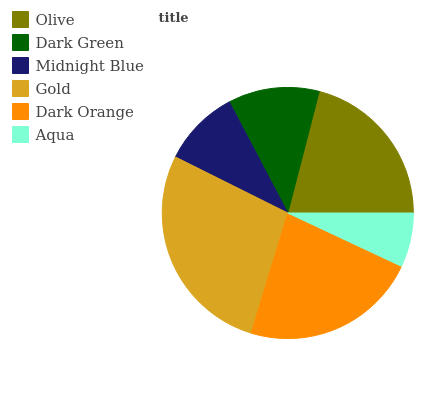Is Aqua the minimum?
Answer yes or no. Yes. Is Gold the maximum?
Answer yes or no. Yes. Is Dark Green the minimum?
Answer yes or no. No. Is Dark Green the maximum?
Answer yes or no. No. Is Olive greater than Dark Green?
Answer yes or no. Yes. Is Dark Green less than Olive?
Answer yes or no. Yes. Is Dark Green greater than Olive?
Answer yes or no. No. Is Olive less than Dark Green?
Answer yes or no. No. Is Olive the high median?
Answer yes or no. Yes. Is Dark Green the low median?
Answer yes or no. Yes. Is Aqua the high median?
Answer yes or no. No. Is Aqua the low median?
Answer yes or no. No. 